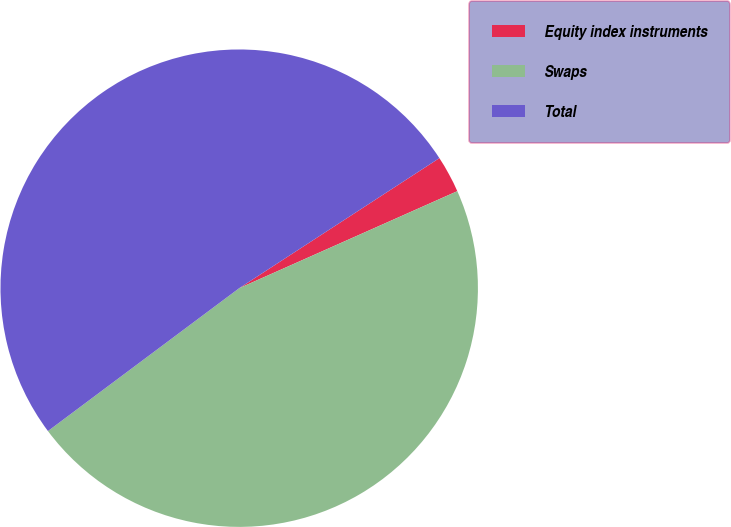Convert chart. <chart><loc_0><loc_0><loc_500><loc_500><pie_chart><fcel>Equity index instruments<fcel>Swaps<fcel>Total<nl><fcel>2.51%<fcel>46.45%<fcel>51.04%<nl></chart> 